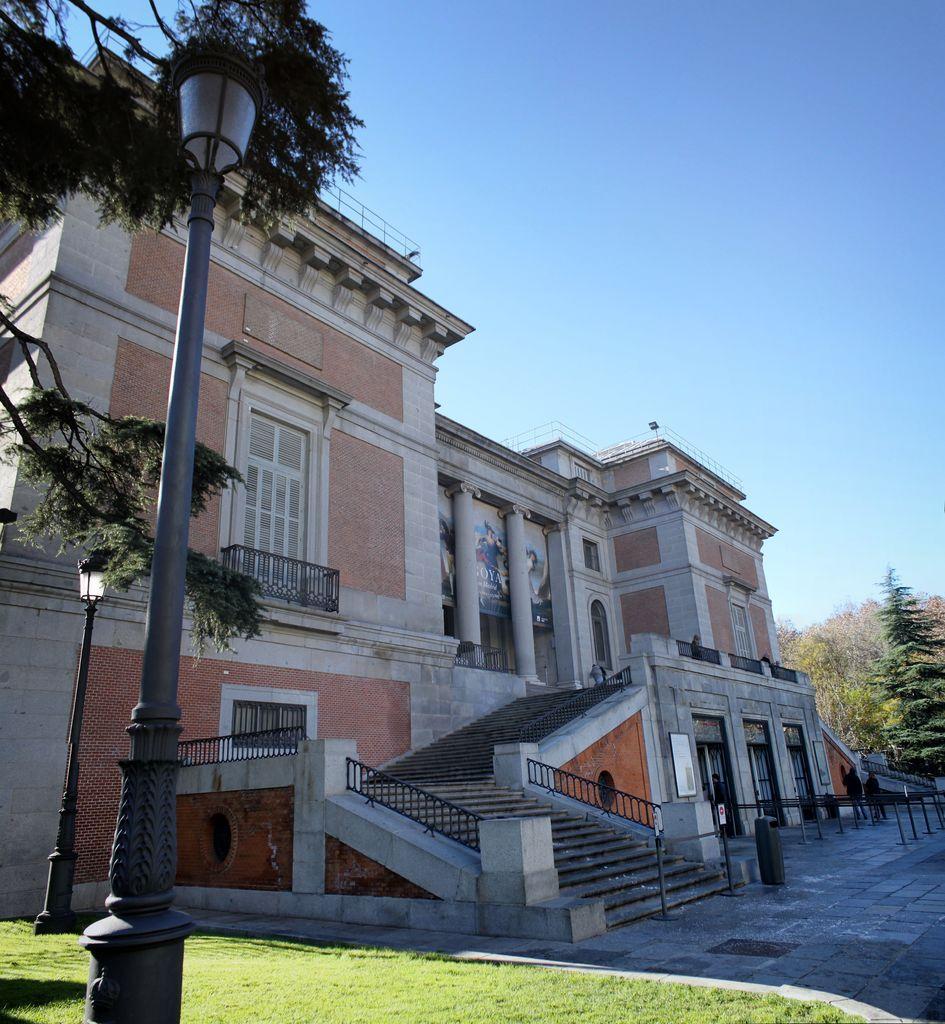Can you describe this image briefly? In the center of the image there is a building with staircase. At the top of the image there is sky. There is a light pole. At the bottom of the image there is grass. To the right side of the image there are trees. 